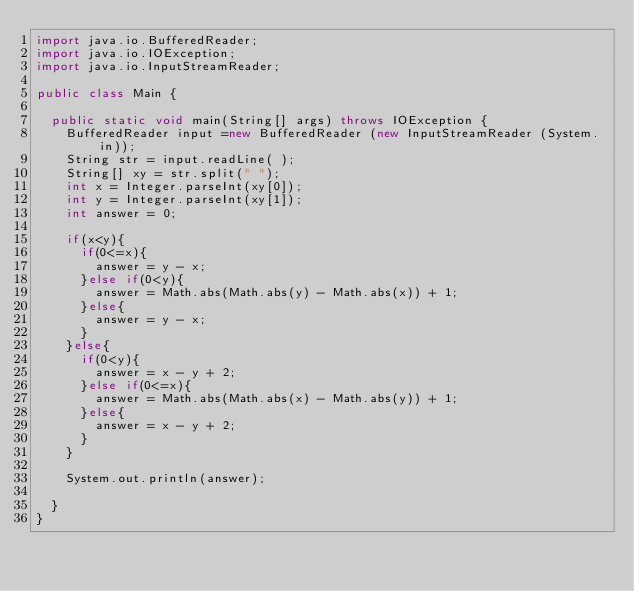<code> <loc_0><loc_0><loc_500><loc_500><_Java_>import java.io.BufferedReader;
import java.io.IOException;
import java.io.InputStreamReader;

public class Main {

	public static void main(String[] args) throws IOException {
		BufferedReader input =new BufferedReader (new InputStreamReader (System.in));
		String str = input.readLine( );
		String[] xy = str.split(" ");
		int x = Integer.parseInt(xy[0]);
		int y = Integer.parseInt(xy[1]);
		int answer = 0;

		if(x<y){
			if(0<=x){
				answer = y - x;
			}else if(0<y){
				answer = Math.abs(Math.abs(y) - Math.abs(x)) + 1;
			}else{
				answer = y - x;
			}
		}else{
			if(0<y){
				answer = x - y + 2;
			}else if(0<=x){
				answer = Math.abs(Math.abs(x) - Math.abs(y)) + 1;
			}else{
				answer = x - y + 2;
			}
		}

		System.out.println(answer);

	}
}
</code> 